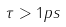Convert formula to latex. <formula><loc_0><loc_0><loc_500><loc_500>\tau > 1 p s</formula> 